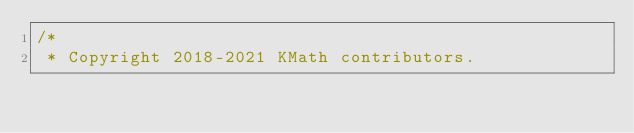<code> <loc_0><loc_0><loc_500><loc_500><_Kotlin_>/*
 * Copyright 2018-2021 KMath contributors.</code> 